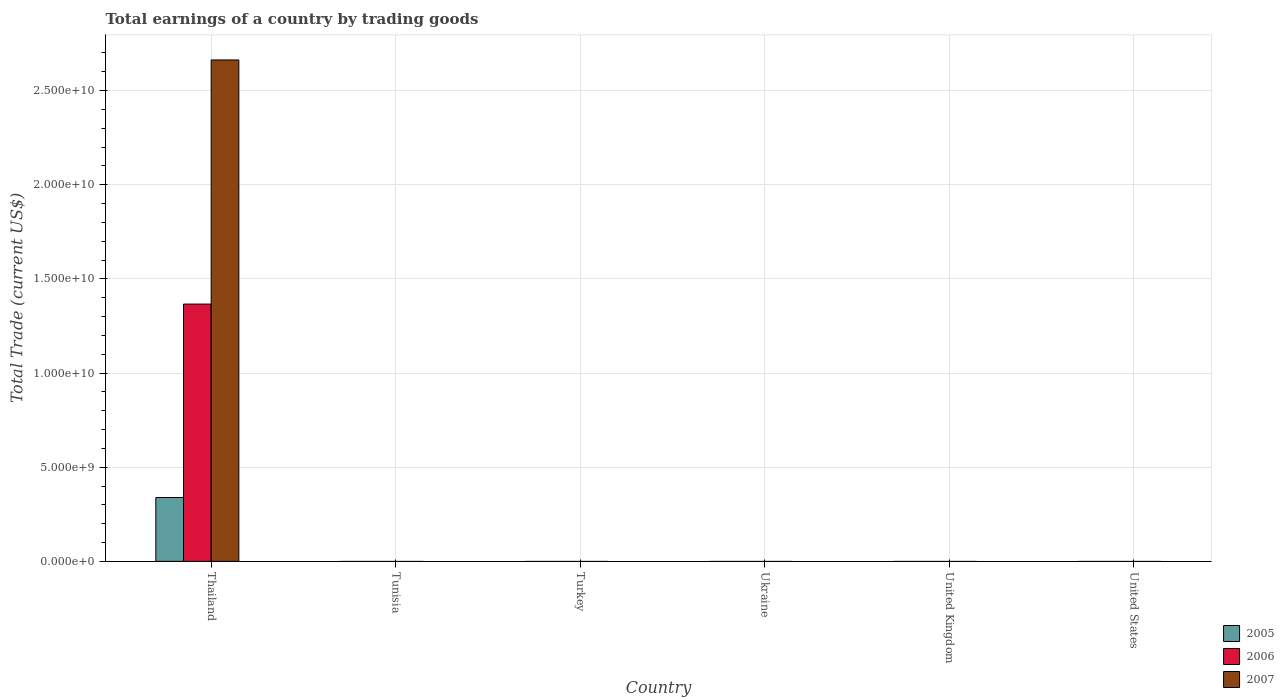Are the number of bars per tick equal to the number of legend labels?
Offer a very short reply. No. How many bars are there on the 1st tick from the left?
Give a very brief answer. 3. What is the label of the 1st group of bars from the left?
Your response must be concise. Thailand. In how many cases, is the number of bars for a given country not equal to the number of legend labels?
Keep it short and to the point. 5. Across all countries, what is the maximum total earnings in 2007?
Provide a succinct answer. 2.66e+1. In which country was the total earnings in 2007 maximum?
Offer a very short reply. Thailand. What is the total total earnings in 2006 in the graph?
Give a very brief answer. 1.37e+1. What is the average total earnings in 2007 per country?
Make the answer very short. 4.44e+09. What is the difference between the total earnings of/in 2005 and total earnings of/in 2006 in Thailand?
Your answer should be very brief. -1.03e+1. What is the difference between the highest and the lowest total earnings in 2006?
Give a very brief answer. 1.37e+1. Is it the case that in every country, the sum of the total earnings in 2005 and total earnings in 2006 is greater than the total earnings in 2007?
Make the answer very short. No. Are all the bars in the graph horizontal?
Provide a short and direct response. No. What is the difference between two consecutive major ticks on the Y-axis?
Offer a terse response. 5.00e+09. Does the graph contain grids?
Your answer should be very brief. Yes. Where does the legend appear in the graph?
Your answer should be compact. Bottom right. What is the title of the graph?
Give a very brief answer. Total earnings of a country by trading goods. What is the label or title of the Y-axis?
Your response must be concise. Total Trade (current US$). What is the Total Trade (current US$) in 2005 in Thailand?
Provide a succinct answer. 3.39e+09. What is the Total Trade (current US$) in 2006 in Thailand?
Ensure brevity in your answer.  1.37e+1. What is the Total Trade (current US$) of 2007 in Thailand?
Provide a short and direct response. 2.66e+1. What is the Total Trade (current US$) of 2005 in Tunisia?
Your answer should be very brief. 0. What is the Total Trade (current US$) of 2006 in Tunisia?
Keep it short and to the point. 0. What is the Total Trade (current US$) of 2005 in Turkey?
Provide a succinct answer. 0. What is the Total Trade (current US$) of 2006 in Turkey?
Offer a very short reply. 0. What is the Total Trade (current US$) in 2007 in Turkey?
Offer a terse response. 0. What is the Total Trade (current US$) of 2005 in Ukraine?
Your response must be concise. 0. What is the Total Trade (current US$) in 2005 in United States?
Keep it short and to the point. 0. What is the Total Trade (current US$) in 2006 in United States?
Your response must be concise. 0. What is the Total Trade (current US$) of 2007 in United States?
Your answer should be compact. 0. Across all countries, what is the maximum Total Trade (current US$) of 2005?
Offer a terse response. 3.39e+09. Across all countries, what is the maximum Total Trade (current US$) of 2006?
Offer a terse response. 1.37e+1. Across all countries, what is the maximum Total Trade (current US$) of 2007?
Your answer should be very brief. 2.66e+1. Across all countries, what is the minimum Total Trade (current US$) of 2005?
Offer a very short reply. 0. What is the total Total Trade (current US$) of 2005 in the graph?
Offer a terse response. 3.39e+09. What is the total Total Trade (current US$) in 2006 in the graph?
Your response must be concise. 1.37e+1. What is the total Total Trade (current US$) of 2007 in the graph?
Make the answer very short. 2.66e+1. What is the average Total Trade (current US$) of 2005 per country?
Your response must be concise. 5.65e+08. What is the average Total Trade (current US$) of 2006 per country?
Give a very brief answer. 2.28e+09. What is the average Total Trade (current US$) in 2007 per country?
Your answer should be very brief. 4.44e+09. What is the difference between the Total Trade (current US$) of 2005 and Total Trade (current US$) of 2006 in Thailand?
Offer a terse response. -1.03e+1. What is the difference between the Total Trade (current US$) in 2005 and Total Trade (current US$) in 2007 in Thailand?
Keep it short and to the point. -2.32e+1. What is the difference between the Total Trade (current US$) of 2006 and Total Trade (current US$) of 2007 in Thailand?
Your response must be concise. -1.30e+1. What is the difference between the highest and the lowest Total Trade (current US$) of 2005?
Keep it short and to the point. 3.39e+09. What is the difference between the highest and the lowest Total Trade (current US$) of 2006?
Your answer should be very brief. 1.37e+1. What is the difference between the highest and the lowest Total Trade (current US$) in 2007?
Ensure brevity in your answer.  2.66e+1. 